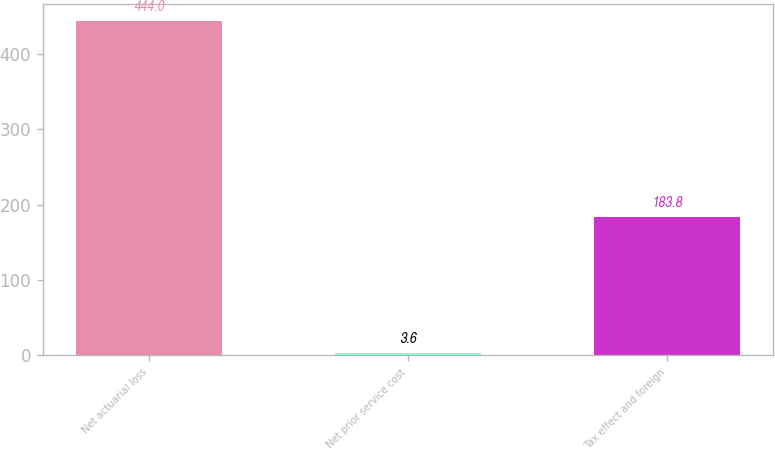Convert chart. <chart><loc_0><loc_0><loc_500><loc_500><bar_chart><fcel>Net actuarial loss<fcel>Net prior service cost<fcel>Tax effect and foreign<nl><fcel>444<fcel>3.6<fcel>183.8<nl></chart> 